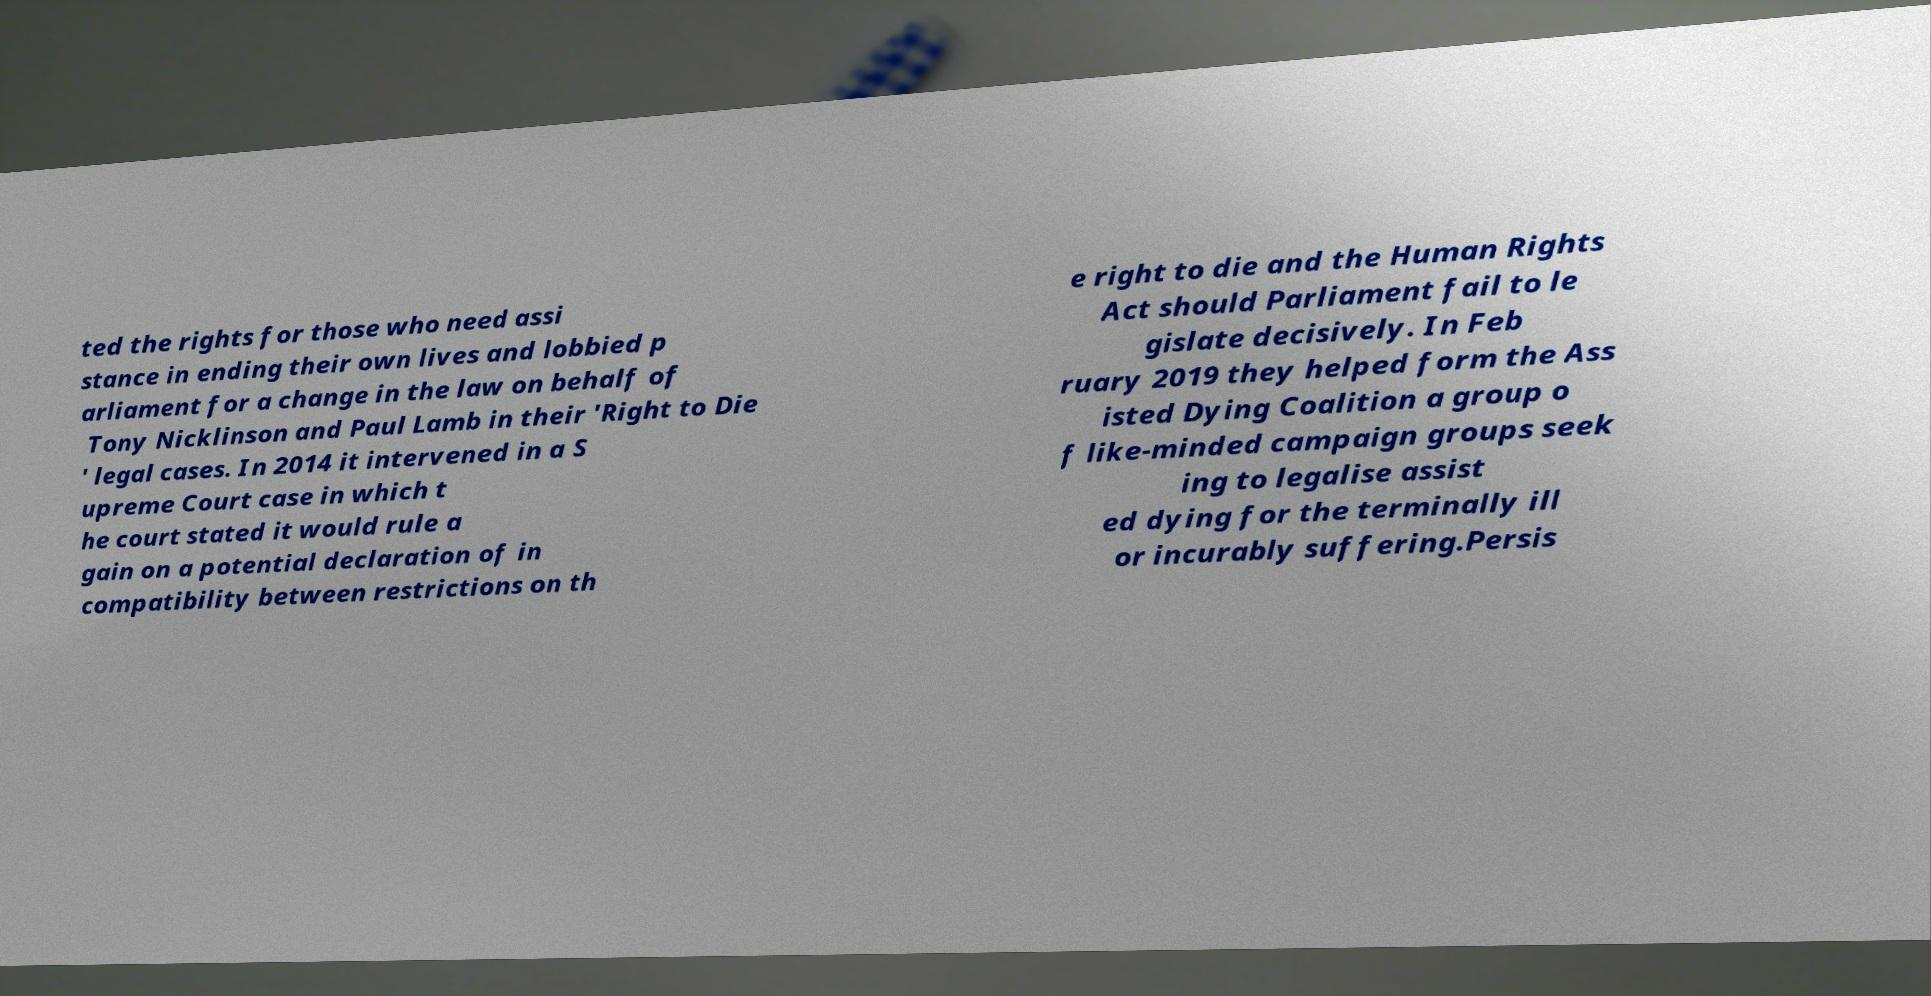Could you assist in decoding the text presented in this image and type it out clearly? ted the rights for those who need assi stance in ending their own lives and lobbied p arliament for a change in the law on behalf of Tony Nicklinson and Paul Lamb in their 'Right to Die ' legal cases. In 2014 it intervened in a S upreme Court case in which t he court stated it would rule a gain on a potential declaration of in compatibility between restrictions on th e right to die and the Human Rights Act should Parliament fail to le gislate decisively. In Feb ruary 2019 they helped form the Ass isted Dying Coalition a group o f like-minded campaign groups seek ing to legalise assist ed dying for the terminally ill or incurably suffering.Persis 